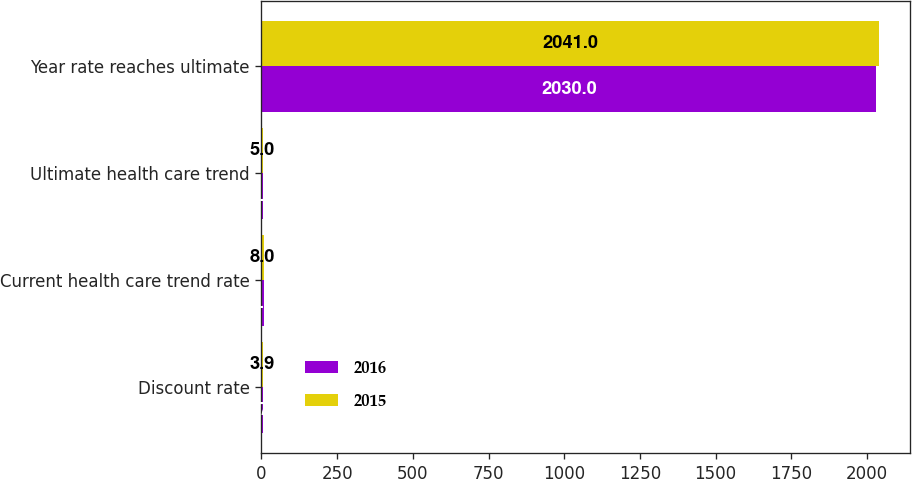<chart> <loc_0><loc_0><loc_500><loc_500><stacked_bar_chart><ecel><fcel>Discount rate<fcel>Current health care trend rate<fcel>Ultimate health care trend<fcel>Year rate reaches ultimate<nl><fcel>2016<fcel>3.75<fcel>7<fcel>5<fcel>2030<nl><fcel>2015<fcel>3.9<fcel>8<fcel>5<fcel>2041<nl></chart> 